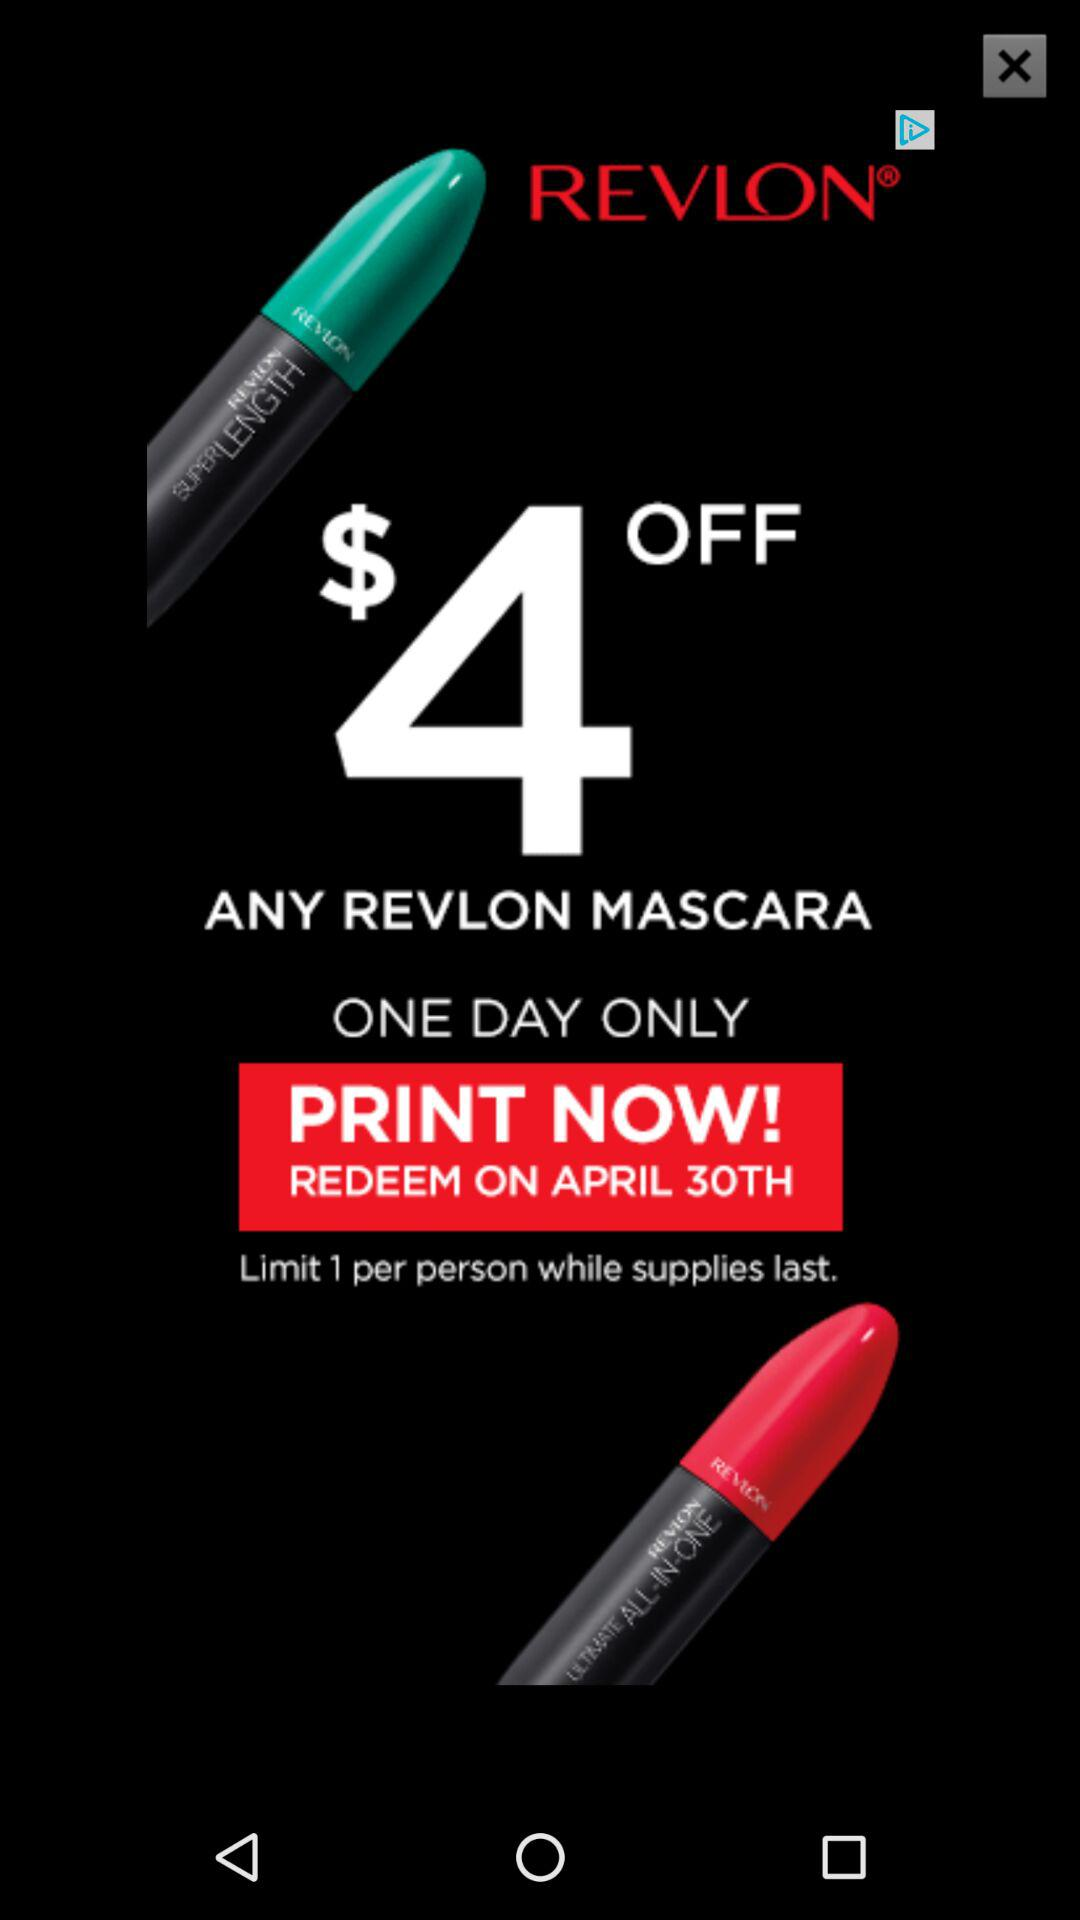How much money is the offer worth?
Answer the question using a single word or phrase. $4 